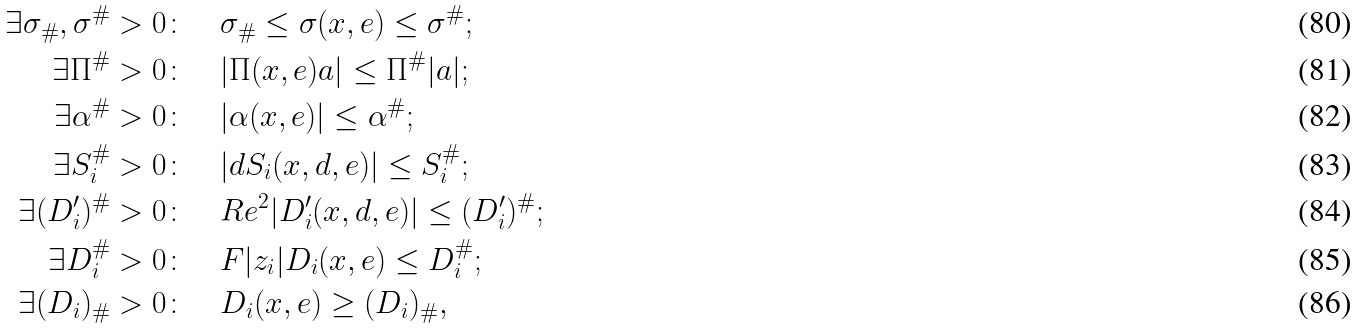Convert formula to latex. <formula><loc_0><loc_0><loc_500><loc_500>\exists \sigma _ { \# } , \sigma ^ { \# } > 0 \colon \quad & \sigma _ { \# } \leq \sigma ( x , e ) \leq \sigma ^ { \# } ; \\ \exists \Pi ^ { \# } > 0 \colon \quad & | \Pi ( x , e ) { a } | \leq \Pi ^ { \# } | { a } | ; \\ \exists \alpha ^ { \# } > 0 \colon \quad & | \alpha ( x , e ) | \leq \alpha ^ { \# } ; \\ \exists S _ { i } ^ { \# } > 0 \colon \quad & | d S _ { i } ( x , d , e ) | \leq S _ { i } ^ { \# } ; \\ \exists ( D _ { i } ^ { \prime } ) ^ { \# } > 0 \colon \quad & R e ^ { 2 } | D _ { i } ^ { \prime } ( x , d , e ) | \leq ( D _ { i } ^ { \prime } ) ^ { \# } ; \\ \exists D _ { i } ^ { \# } > 0 \colon \quad & F | z _ { i } | D _ { i } ( x , e ) \leq D _ { i } ^ { \# } ; \\ \exists ( D _ { i } ) _ { \# } > 0 \colon \quad & D _ { i } ( x , e ) \geq ( D _ { i } ) _ { \# } ,</formula> 